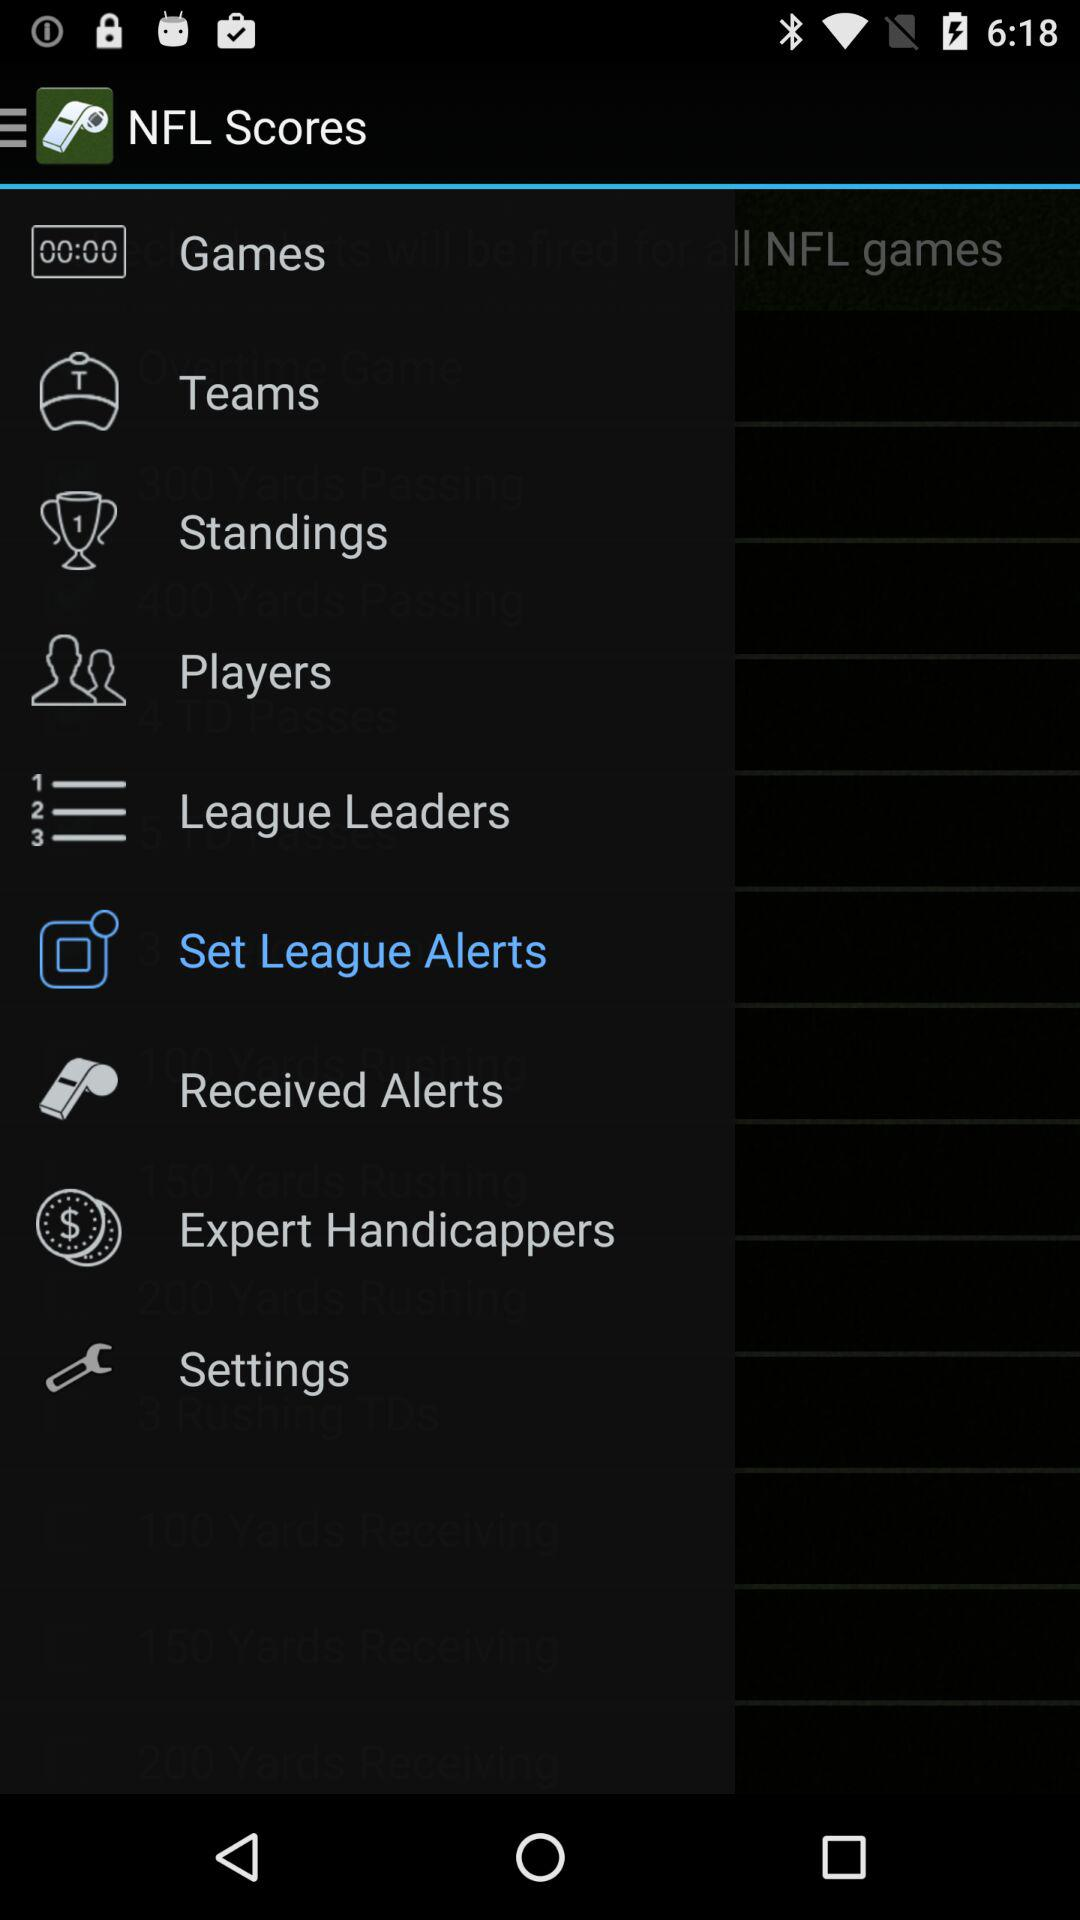What is the name of the application? The name of the application is "NFL Scores". 